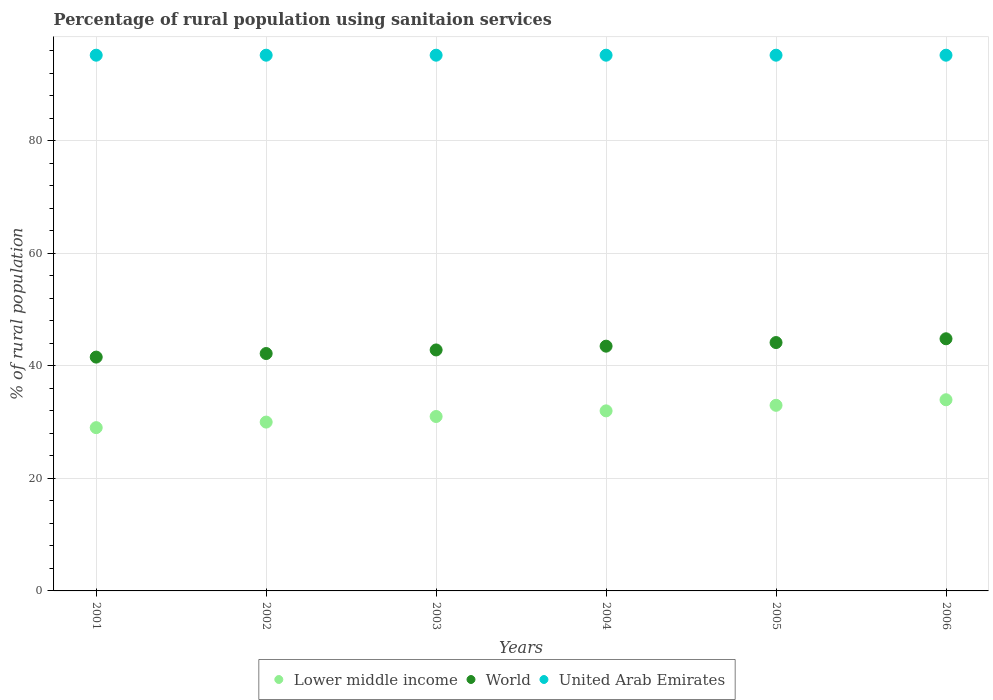How many different coloured dotlines are there?
Offer a very short reply. 3. Is the number of dotlines equal to the number of legend labels?
Ensure brevity in your answer.  Yes. What is the percentage of rural population using sanitaion services in World in 2003?
Keep it short and to the point. 42.82. Across all years, what is the maximum percentage of rural population using sanitaion services in Lower middle income?
Your answer should be very brief. 33.97. Across all years, what is the minimum percentage of rural population using sanitaion services in World?
Keep it short and to the point. 41.55. In which year was the percentage of rural population using sanitaion services in World minimum?
Ensure brevity in your answer.  2001. What is the total percentage of rural population using sanitaion services in United Arab Emirates in the graph?
Provide a short and direct response. 571.2. What is the difference between the percentage of rural population using sanitaion services in Lower middle income in 2004 and the percentage of rural population using sanitaion services in World in 2001?
Provide a short and direct response. -9.55. What is the average percentage of rural population using sanitaion services in World per year?
Your answer should be compact. 43.17. In the year 2001, what is the difference between the percentage of rural population using sanitaion services in United Arab Emirates and percentage of rural population using sanitaion services in World?
Offer a very short reply. 53.65. In how many years, is the percentage of rural population using sanitaion services in United Arab Emirates greater than 20 %?
Provide a short and direct response. 6. What is the ratio of the percentage of rural population using sanitaion services in Lower middle income in 2003 to that in 2004?
Offer a terse response. 0.97. Is the percentage of rural population using sanitaion services in United Arab Emirates in 2004 less than that in 2006?
Offer a terse response. No. Is the difference between the percentage of rural population using sanitaion services in United Arab Emirates in 2004 and 2005 greater than the difference between the percentage of rural population using sanitaion services in World in 2004 and 2005?
Keep it short and to the point. Yes. What is the difference between the highest and the lowest percentage of rural population using sanitaion services in World?
Your answer should be compact. 3.26. In how many years, is the percentage of rural population using sanitaion services in Lower middle income greater than the average percentage of rural population using sanitaion services in Lower middle income taken over all years?
Keep it short and to the point. 3. Is it the case that in every year, the sum of the percentage of rural population using sanitaion services in United Arab Emirates and percentage of rural population using sanitaion services in World  is greater than the percentage of rural population using sanitaion services in Lower middle income?
Give a very brief answer. Yes. Does the percentage of rural population using sanitaion services in Lower middle income monotonically increase over the years?
Ensure brevity in your answer.  Yes. Is the percentage of rural population using sanitaion services in United Arab Emirates strictly greater than the percentage of rural population using sanitaion services in Lower middle income over the years?
Offer a terse response. Yes. Is the percentage of rural population using sanitaion services in Lower middle income strictly less than the percentage of rural population using sanitaion services in World over the years?
Your response must be concise. Yes. How many years are there in the graph?
Ensure brevity in your answer.  6. What is the difference between two consecutive major ticks on the Y-axis?
Provide a succinct answer. 20. Does the graph contain any zero values?
Ensure brevity in your answer.  No. Does the graph contain grids?
Offer a terse response. Yes. Where does the legend appear in the graph?
Your answer should be compact. Bottom center. What is the title of the graph?
Your answer should be very brief. Percentage of rural population using sanitaion services. What is the label or title of the X-axis?
Give a very brief answer. Years. What is the label or title of the Y-axis?
Offer a very short reply. % of rural population. What is the % of rural population in Lower middle income in 2001?
Keep it short and to the point. 29.02. What is the % of rural population of World in 2001?
Your response must be concise. 41.55. What is the % of rural population of United Arab Emirates in 2001?
Offer a terse response. 95.2. What is the % of rural population in Lower middle income in 2002?
Your answer should be very brief. 30. What is the % of rural population of World in 2002?
Offer a terse response. 42.19. What is the % of rural population in United Arab Emirates in 2002?
Keep it short and to the point. 95.2. What is the % of rural population in Lower middle income in 2003?
Offer a very short reply. 31. What is the % of rural population in World in 2003?
Offer a very short reply. 42.82. What is the % of rural population of United Arab Emirates in 2003?
Provide a short and direct response. 95.2. What is the % of rural population in Lower middle income in 2004?
Offer a very short reply. 32. What is the % of rural population in World in 2004?
Provide a succinct answer. 43.49. What is the % of rural population of United Arab Emirates in 2004?
Offer a very short reply. 95.2. What is the % of rural population in Lower middle income in 2005?
Ensure brevity in your answer.  32.98. What is the % of rural population in World in 2005?
Ensure brevity in your answer.  44.14. What is the % of rural population of United Arab Emirates in 2005?
Keep it short and to the point. 95.2. What is the % of rural population in Lower middle income in 2006?
Your answer should be compact. 33.97. What is the % of rural population of World in 2006?
Your answer should be very brief. 44.81. What is the % of rural population of United Arab Emirates in 2006?
Ensure brevity in your answer.  95.2. Across all years, what is the maximum % of rural population in Lower middle income?
Make the answer very short. 33.97. Across all years, what is the maximum % of rural population of World?
Your answer should be compact. 44.81. Across all years, what is the maximum % of rural population of United Arab Emirates?
Offer a very short reply. 95.2. Across all years, what is the minimum % of rural population in Lower middle income?
Provide a short and direct response. 29.02. Across all years, what is the minimum % of rural population of World?
Your answer should be compact. 41.55. Across all years, what is the minimum % of rural population of United Arab Emirates?
Give a very brief answer. 95.2. What is the total % of rural population in Lower middle income in the graph?
Provide a short and direct response. 188.97. What is the total % of rural population of World in the graph?
Provide a short and direct response. 259. What is the total % of rural population in United Arab Emirates in the graph?
Keep it short and to the point. 571.2. What is the difference between the % of rural population of Lower middle income in 2001 and that in 2002?
Provide a short and direct response. -0.99. What is the difference between the % of rural population in World in 2001 and that in 2002?
Your response must be concise. -0.64. What is the difference between the % of rural population in United Arab Emirates in 2001 and that in 2002?
Make the answer very short. 0. What is the difference between the % of rural population in Lower middle income in 2001 and that in 2003?
Offer a terse response. -1.98. What is the difference between the % of rural population in World in 2001 and that in 2003?
Offer a very short reply. -1.27. What is the difference between the % of rural population of Lower middle income in 2001 and that in 2004?
Provide a succinct answer. -2.98. What is the difference between the % of rural population in World in 2001 and that in 2004?
Give a very brief answer. -1.94. What is the difference between the % of rural population of United Arab Emirates in 2001 and that in 2004?
Ensure brevity in your answer.  0. What is the difference between the % of rural population in Lower middle income in 2001 and that in 2005?
Offer a terse response. -3.97. What is the difference between the % of rural population of World in 2001 and that in 2005?
Offer a terse response. -2.59. What is the difference between the % of rural population of Lower middle income in 2001 and that in 2006?
Provide a succinct answer. -4.95. What is the difference between the % of rural population of World in 2001 and that in 2006?
Your answer should be compact. -3.26. What is the difference between the % of rural population in Lower middle income in 2002 and that in 2003?
Your response must be concise. -0.99. What is the difference between the % of rural population of World in 2002 and that in 2003?
Your answer should be very brief. -0.64. What is the difference between the % of rural population in United Arab Emirates in 2002 and that in 2003?
Ensure brevity in your answer.  0. What is the difference between the % of rural population of Lower middle income in 2002 and that in 2004?
Ensure brevity in your answer.  -1.99. What is the difference between the % of rural population of World in 2002 and that in 2004?
Ensure brevity in your answer.  -1.31. What is the difference between the % of rural population in Lower middle income in 2002 and that in 2005?
Provide a short and direct response. -2.98. What is the difference between the % of rural population of World in 2002 and that in 2005?
Ensure brevity in your answer.  -1.95. What is the difference between the % of rural population of Lower middle income in 2002 and that in 2006?
Give a very brief answer. -3.97. What is the difference between the % of rural population of World in 2002 and that in 2006?
Your answer should be very brief. -2.62. What is the difference between the % of rural population in United Arab Emirates in 2002 and that in 2006?
Give a very brief answer. 0. What is the difference between the % of rural population in Lower middle income in 2003 and that in 2004?
Your answer should be compact. -1. What is the difference between the % of rural population of World in 2003 and that in 2004?
Your response must be concise. -0.67. What is the difference between the % of rural population of United Arab Emirates in 2003 and that in 2004?
Your answer should be compact. 0. What is the difference between the % of rural population in Lower middle income in 2003 and that in 2005?
Offer a very short reply. -1.99. What is the difference between the % of rural population in World in 2003 and that in 2005?
Provide a short and direct response. -1.31. What is the difference between the % of rural population in Lower middle income in 2003 and that in 2006?
Your answer should be very brief. -2.97. What is the difference between the % of rural population of World in 2003 and that in 2006?
Offer a very short reply. -1.98. What is the difference between the % of rural population in United Arab Emirates in 2003 and that in 2006?
Your answer should be very brief. 0. What is the difference between the % of rural population in Lower middle income in 2004 and that in 2005?
Your response must be concise. -0.99. What is the difference between the % of rural population in World in 2004 and that in 2005?
Give a very brief answer. -0.64. What is the difference between the % of rural population of Lower middle income in 2004 and that in 2006?
Make the answer very short. -1.97. What is the difference between the % of rural population in World in 2004 and that in 2006?
Provide a succinct answer. -1.31. What is the difference between the % of rural population of United Arab Emirates in 2004 and that in 2006?
Keep it short and to the point. 0. What is the difference between the % of rural population in Lower middle income in 2005 and that in 2006?
Make the answer very short. -0.99. What is the difference between the % of rural population in World in 2005 and that in 2006?
Keep it short and to the point. -0.67. What is the difference between the % of rural population of Lower middle income in 2001 and the % of rural population of World in 2002?
Ensure brevity in your answer.  -13.17. What is the difference between the % of rural population of Lower middle income in 2001 and the % of rural population of United Arab Emirates in 2002?
Your answer should be very brief. -66.18. What is the difference between the % of rural population of World in 2001 and the % of rural population of United Arab Emirates in 2002?
Your response must be concise. -53.65. What is the difference between the % of rural population of Lower middle income in 2001 and the % of rural population of World in 2003?
Keep it short and to the point. -13.81. What is the difference between the % of rural population of Lower middle income in 2001 and the % of rural population of United Arab Emirates in 2003?
Make the answer very short. -66.18. What is the difference between the % of rural population in World in 2001 and the % of rural population in United Arab Emirates in 2003?
Make the answer very short. -53.65. What is the difference between the % of rural population of Lower middle income in 2001 and the % of rural population of World in 2004?
Your answer should be compact. -14.48. What is the difference between the % of rural population in Lower middle income in 2001 and the % of rural population in United Arab Emirates in 2004?
Your answer should be very brief. -66.18. What is the difference between the % of rural population in World in 2001 and the % of rural population in United Arab Emirates in 2004?
Ensure brevity in your answer.  -53.65. What is the difference between the % of rural population of Lower middle income in 2001 and the % of rural population of World in 2005?
Make the answer very short. -15.12. What is the difference between the % of rural population in Lower middle income in 2001 and the % of rural population in United Arab Emirates in 2005?
Your answer should be very brief. -66.18. What is the difference between the % of rural population in World in 2001 and the % of rural population in United Arab Emirates in 2005?
Offer a very short reply. -53.65. What is the difference between the % of rural population of Lower middle income in 2001 and the % of rural population of World in 2006?
Provide a succinct answer. -15.79. What is the difference between the % of rural population in Lower middle income in 2001 and the % of rural population in United Arab Emirates in 2006?
Offer a very short reply. -66.18. What is the difference between the % of rural population of World in 2001 and the % of rural population of United Arab Emirates in 2006?
Offer a very short reply. -53.65. What is the difference between the % of rural population of Lower middle income in 2002 and the % of rural population of World in 2003?
Provide a succinct answer. -12.82. What is the difference between the % of rural population of Lower middle income in 2002 and the % of rural population of United Arab Emirates in 2003?
Provide a succinct answer. -65.2. What is the difference between the % of rural population of World in 2002 and the % of rural population of United Arab Emirates in 2003?
Ensure brevity in your answer.  -53.01. What is the difference between the % of rural population in Lower middle income in 2002 and the % of rural population in World in 2004?
Make the answer very short. -13.49. What is the difference between the % of rural population of Lower middle income in 2002 and the % of rural population of United Arab Emirates in 2004?
Your answer should be compact. -65.2. What is the difference between the % of rural population of World in 2002 and the % of rural population of United Arab Emirates in 2004?
Your answer should be compact. -53.01. What is the difference between the % of rural population in Lower middle income in 2002 and the % of rural population in World in 2005?
Make the answer very short. -14.13. What is the difference between the % of rural population of Lower middle income in 2002 and the % of rural population of United Arab Emirates in 2005?
Provide a succinct answer. -65.2. What is the difference between the % of rural population of World in 2002 and the % of rural population of United Arab Emirates in 2005?
Offer a very short reply. -53.01. What is the difference between the % of rural population of Lower middle income in 2002 and the % of rural population of World in 2006?
Provide a succinct answer. -14.8. What is the difference between the % of rural population in Lower middle income in 2002 and the % of rural population in United Arab Emirates in 2006?
Your answer should be very brief. -65.2. What is the difference between the % of rural population of World in 2002 and the % of rural population of United Arab Emirates in 2006?
Give a very brief answer. -53.01. What is the difference between the % of rural population of Lower middle income in 2003 and the % of rural population of World in 2004?
Provide a succinct answer. -12.5. What is the difference between the % of rural population of Lower middle income in 2003 and the % of rural population of United Arab Emirates in 2004?
Your answer should be very brief. -64.2. What is the difference between the % of rural population in World in 2003 and the % of rural population in United Arab Emirates in 2004?
Offer a very short reply. -52.38. What is the difference between the % of rural population of Lower middle income in 2003 and the % of rural population of World in 2005?
Ensure brevity in your answer.  -13.14. What is the difference between the % of rural population in Lower middle income in 2003 and the % of rural population in United Arab Emirates in 2005?
Keep it short and to the point. -64.2. What is the difference between the % of rural population in World in 2003 and the % of rural population in United Arab Emirates in 2005?
Your response must be concise. -52.38. What is the difference between the % of rural population of Lower middle income in 2003 and the % of rural population of World in 2006?
Your answer should be compact. -13.81. What is the difference between the % of rural population in Lower middle income in 2003 and the % of rural population in United Arab Emirates in 2006?
Ensure brevity in your answer.  -64.2. What is the difference between the % of rural population of World in 2003 and the % of rural population of United Arab Emirates in 2006?
Make the answer very short. -52.38. What is the difference between the % of rural population of Lower middle income in 2004 and the % of rural population of World in 2005?
Keep it short and to the point. -12.14. What is the difference between the % of rural population of Lower middle income in 2004 and the % of rural population of United Arab Emirates in 2005?
Your response must be concise. -63.2. What is the difference between the % of rural population in World in 2004 and the % of rural population in United Arab Emirates in 2005?
Offer a very short reply. -51.71. What is the difference between the % of rural population in Lower middle income in 2004 and the % of rural population in World in 2006?
Make the answer very short. -12.81. What is the difference between the % of rural population in Lower middle income in 2004 and the % of rural population in United Arab Emirates in 2006?
Your answer should be very brief. -63.2. What is the difference between the % of rural population in World in 2004 and the % of rural population in United Arab Emirates in 2006?
Your answer should be compact. -51.71. What is the difference between the % of rural population of Lower middle income in 2005 and the % of rural population of World in 2006?
Make the answer very short. -11.82. What is the difference between the % of rural population of Lower middle income in 2005 and the % of rural population of United Arab Emirates in 2006?
Give a very brief answer. -62.22. What is the difference between the % of rural population in World in 2005 and the % of rural population in United Arab Emirates in 2006?
Offer a very short reply. -51.06. What is the average % of rural population in Lower middle income per year?
Provide a succinct answer. 31.49. What is the average % of rural population of World per year?
Your response must be concise. 43.17. What is the average % of rural population of United Arab Emirates per year?
Your response must be concise. 95.2. In the year 2001, what is the difference between the % of rural population in Lower middle income and % of rural population in World?
Give a very brief answer. -12.53. In the year 2001, what is the difference between the % of rural population in Lower middle income and % of rural population in United Arab Emirates?
Make the answer very short. -66.18. In the year 2001, what is the difference between the % of rural population in World and % of rural population in United Arab Emirates?
Ensure brevity in your answer.  -53.65. In the year 2002, what is the difference between the % of rural population of Lower middle income and % of rural population of World?
Offer a very short reply. -12.18. In the year 2002, what is the difference between the % of rural population in Lower middle income and % of rural population in United Arab Emirates?
Offer a terse response. -65.2. In the year 2002, what is the difference between the % of rural population in World and % of rural population in United Arab Emirates?
Keep it short and to the point. -53.01. In the year 2003, what is the difference between the % of rural population of Lower middle income and % of rural population of World?
Your response must be concise. -11.83. In the year 2003, what is the difference between the % of rural population of Lower middle income and % of rural population of United Arab Emirates?
Ensure brevity in your answer.  -64.2. In the year 2003, what is the difference between the % of rural population of World and % of rural population of United Arab Emirates?
Your answer should be very brief. -52.38. In the year 2004, what is the difference between the % of rural population of Lower middle income and % of rural population of World?
Provide a short and direct response. -11.5. In the year 2004, what is the difference between the % of rural population in Lower middle income and % of rural population in United Arab Emirates?
Give a very brief answer. -63.2. In the year 2004, what is the difference between the % of rural population in World and % of rural population in United Arab Emirates?
Provide a succinct answer. -51.71. In the year 2005, what is the difference between the % of rural population in Lower middle income and % of rural population in World?
Your response must be concise. -11.15. In the year 2005, what is the difference between the % of rural population in Lower middle income and % of rural population in United Arab Emirates?
Your response must be concise. -62.22. In the year 2005, what is the difference between the % of rural population in World and % of rural population in United Arab Emirates?
Offer a very short reply. -51.06. In the year 2006, what is the difference between the % of rural population of Lower middle income and % of rural population of World?
Your answer should be compact. -10.84. In the year 2006, what is the difference between the % of rural population in Lower middle income and % of rural population in United Arab Emirates?
Offer a terse response. -61.23. In the year 2006, what is the difference between the % of rural population of World and % of rural population of United Arab Emirates?
Offer a terse response. -50.39. What is the ratio of the % of rural population in Lower middle income in 2001 to that in 2002?
Make the answer very short. 0.97. What is the ratio of the % of rural population of World in 2001 to that in 2002?
Provide a short and direct response. 0.98. What is the ratio of the % of rural population of Lower middle income in 2001 to that in 2003?
Offer a very short reply. 0.94. What is the ratio of the % of rural population of World in 2001 to that in 2003?
Your answer should be compact. 0.97. What is the ratio of the % of rural population of United Arab Emirates in 2001 to that in 2003?
Your answer should be compact. 1. What is the ratio of the % of rural population of Lower middle income in 2001 to that in 2004?
Your answer should be compact. 0.91. What is the ratio of the % of rural population of World in 2001 to that in 2004?
Your answer should be very brief. 0.96. What is the ratio of the % of rural population in United Arab Emirates in 2001 to that in 2004?
Your response must be concise. 1. What is the ratio of the % of rural population of Lower middle income in 2001 to that in 2005?
Give a very brief answer. 0.88. What is the ratio of the % of rural population in World in 2001 to that in 2005?
Provide a succinct answer. 0.94. What is the ratio of the % of rural population of United Arab Emirates in 2001 to that in 2005?
Make the answer very short. 1. What is the ratio of the % of rural population of Lower middle income in 2001 to that in 2006?
Your response must be concise. 0.85. What is the ratio of the % of rural population of World in 2001 to that in 2006?
Offer a very short reply. 0.93. What is the ratio of the % of rural population in United Arab Emirates in 2001 to that in 2006?
Provide a succinct answer. 1. What is the ratio of the % of rural population in World in 2002 to that in 2003?
Your answer should be very brief. 0.99. What is the ratio of the % of rural population of United Arab Emirates in 2002 to that in 2003?
Provide a short and direct response. 1. What is the ratio of the % of rural population of Lower middle income in 2002 to that in 2004?
Offer a terse response. 0.94. What is the ratio of the % of rural population of World in 2002 to that in 2004?
Ensure brevity in your answer.  0.97. What is the ratio of the % of rural population of United Arab Emirates in 2002 to that in 2004?
Your answer should be very brief. 1. What is the ratio of the % of rural population of Lower middle income in 2002 to that in 2005?
Your answer should be compact. 0.91. What is the ratio of the % of rural population of World in 2002 to that in 2005?
Provide a succinct answer. 0.96. What is the ratio of the % of rural population of Lower middle income in 2002 to that in 2006?
Provide a succinct answer. 0.88. What is the ratio of the % of rural population of World in 2002 to that in 2006?
Provide a short and direct response. 0.94. What is the ratio of the % of rural population of United Arab Emirates in 2002 to that in 2006?
Ensure brevity in your answer.  1. What is the ratio of the % of rural population of Lower middle income in 2003 to that in 2004?
Make the answer very short. 0.97. What is the ratio of the % of rural population in World in 2003 to that in 2004?
Keep it short and to the point. 0.98. What is the ratio of the % of rural population in Lower middle income in 2003 to that in 2005?
Your answer should be compact. 0.94. What is the ratio of the % of rural population of World in 2003 to that in 2005?
Offer a terse response. 0.97. What is the ratio of the % of rural population in Lower middle income in 2003 to that in 2006?
Keep it short and to the point. 0.91. What is the ratio of the % of rural population in World in 2003 to that in 2006?
Make the answer very short. 0.96. What is the ratio of the % of rural population of United Arab Emirates in 2003 to that in 2006?
Offer a very short reply. 1. What is the ratio of the % of rural population of Lower middle income in 2004 to that in 2005?
Make the answer very short. 0.97. What is the ratio of the % of rural population in World in 2004 to that in 2005?
Provide a short and direct response. 0.99. What is the ratio of the % of rural population of United Arab Emirates in 2004 to that in 2005?
Keep it short and to the point. 1. What is the ratio of the % of rural population in Lower middle income in 2004 to that in 2006?
Offer a terse response. 0.94. What is the ratio of the % of rural population of World in 2004 to that in 2006?
Offer a very short reply. 0.97. What is the ratio of the % of rural population of United Arab Emirates in 2004 to that in 2006?
Your answer should be very brief. 1. What is the ratio of the % of rural population in United Arab Emirates in 2005 to that in 2006?
Offer a very short reply. 1. What is the difference between the highest and the second highest % of rural population of Lower middle income?
Your answer should be very brief. 0.99. What is the difference between the highest and the second highest % of rural population in World?
Your response must be concise. 0.67. What is the difference between the highest and the second highest % of rural population of United Arab Emirates?
Your answer should be very brief. 0. What is the difference between the highest and the lowest % of rural population in Lower middle income?
Provide a short and direct response. 4.95. What is the difference between the highest and the lowest % of rural population of World?
Keep it short and to the point. 3.26. 